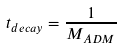Convert formula to latex. <formula><loc_0><loc_0><loc_500><loc_500>t _ { d e c a y } = \frac { 1 } { M _ { A D M } }</formula> 